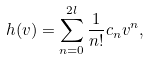Convert formula to latex. <formula><loc_0><loc_0><loc_500><loc_500>h ( v ) = \sum _ { n = 0 } ^ { 2 l } \frac { 1 } { n ! } c _ { n } v ^ { n } ,</formula> 